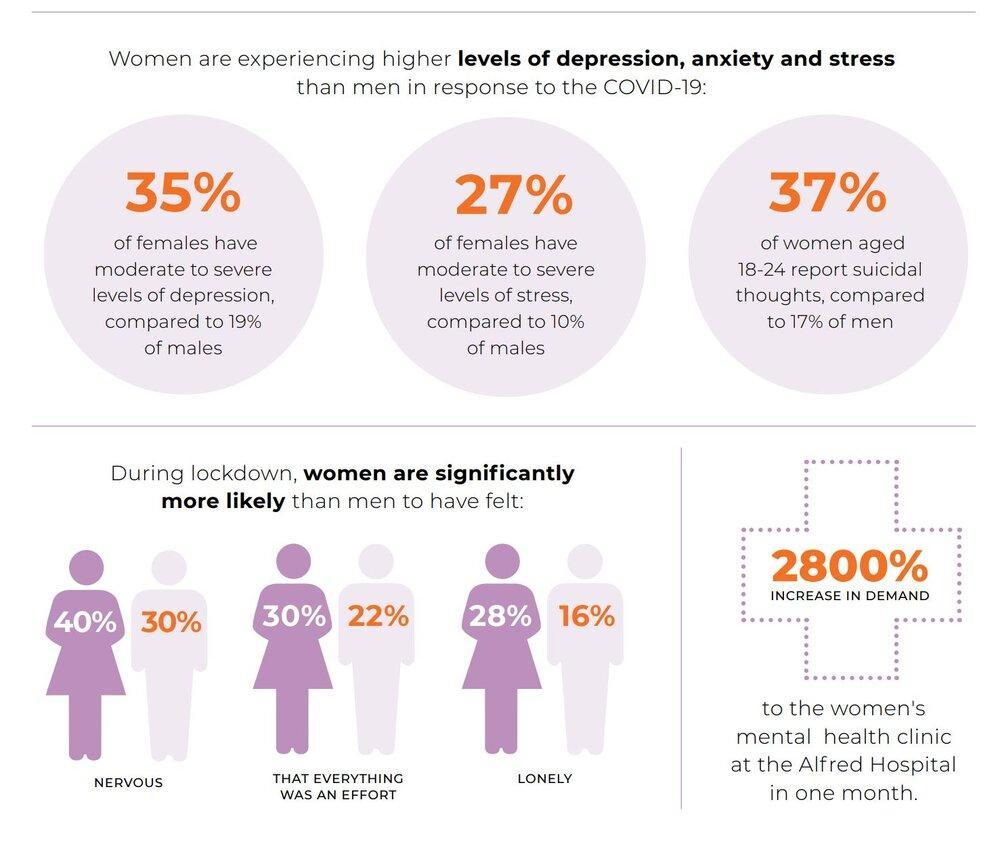What percentage of women felt nervous during the lockdown period?
Answer the question with a short phrase. 40% What percentage of men felt nervous during the lockdown period? 30% What percentage of women felt lonely during the lockdown period? 28% What percentage of women aged 18-24 reported suicidal thoughts during the lockdown period? 37% What percentage of women felt that everything was an effort during the lockdown period? 30% What percentage of men had moderate to severe levels of depression during the lockdown period? 19% What percentage of men had moderate to severe levels of stress during the lockdown period? 10% 